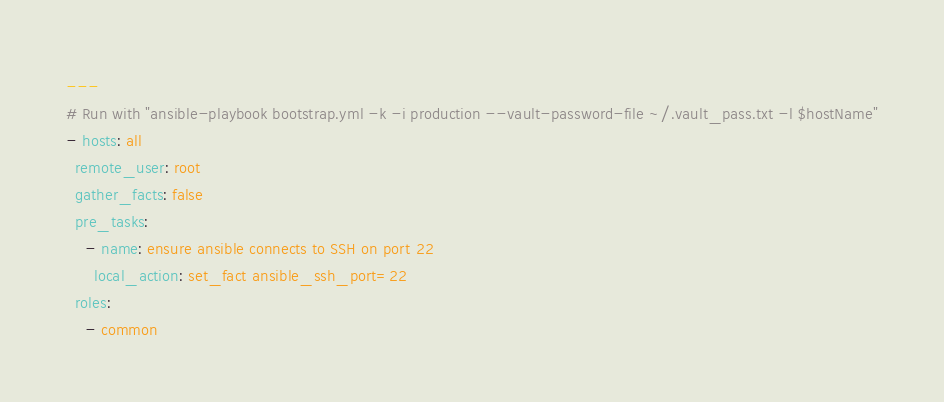<code> <loc_0><loc_0><loc_500><loc_500><_YAML_>---
# Run with "ansible-playbook bootstrap.yml -k -i production --vault-password-file ~/.vault_pass.txt -l $hostName"
- hosts: all
  remote_user: root
  gather_facts: false
  pre_tasks:
    - name: ensure ansible connects to SSH on port 22
      local_action: set_fact ansible_ssh_port=22
  roles:
    - common
</code> 